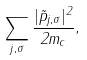<formula> <loc_0><loc_0><loc_500><loc_500>\sum _ { j , \sigma } \frac { | \vec { p } _ { j , \sigma } | ^ { 2 } } { 2 m _ { c } } ,</formula> 